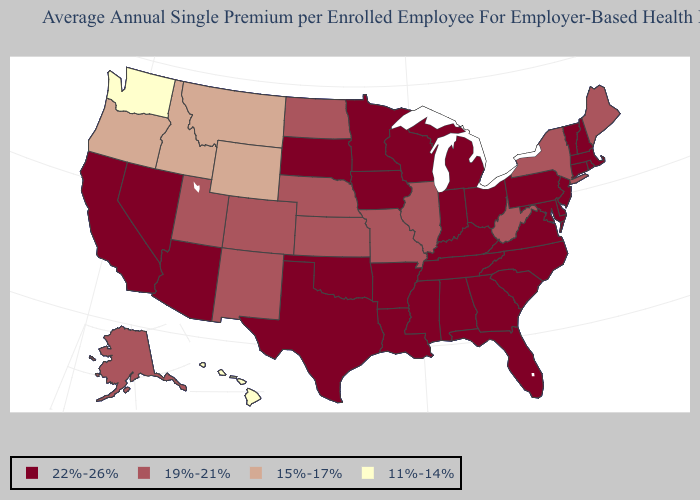What is the highest value in the USA?
Answer briefly. 22%-26%. Name the states that have a value in the range 22%-26%?
Be succinct. Alabama, Arizona, Arkansas, California, Connecticut, Delaware, Florida, Georgia, Indiana, Iowa, Kentucky, Louisiana, Maryland, Massachusetts, Michigan, Minnesota, Mississippi, Nevada, New Hampshire, New Jersey, North Carolina, Ohio, Oklahoma, Pennsylvania, Rhode Island, South Carolina, South Dakota, Tennessee, Texas, Vermont, Virginia, Wisconsin. What is the value of New Hampshire?
Give a very brief answer. 22%-26%. What is the lowest value in the USA?
Give a very brief answer. 11%-14%. What is the highest value in states that border Washington?
Keep it brief. 15%-17%. Name the states that have a value in the range 22%-26%?
Keep it brief. Alabama, Arizona, Arkansas, California, Connecticut, Delaware, Florida, Georgia, Indiana, Iowa, Kentucky, Louisiana, Maryland, Massachusetts, Michigan, Minnesota, Mississippi, Nevada, New Hampshire, New Jersey, North Carolina, Ohio, Oklahoma, Pennsylvania, Rhode Island, South Carolina, South Dakota, Tennessee, Texas, Vermont, Virginia, Wisconsin. Name the states that have a value in the range 19%-21%?
Answer briefly. Alaska, Colorado, Illinois, Kansas, Maine, Missouri, Nebraska, New Mexico, New York, North Dakota, Utah, West Virginia. Among the states that border California , which have the highest value?
Keep it brief. Arizona, Nevada. What is the value of Oregon?
Be succinct. 15%-17%. Does the map have missing data?
Keep it brief. No. Name the states that have a value in the range 19%-21%?
Concise answer only. Alaska, Colorado, Illinois, Kansas, Maine, Missouri, Nebraska, New Mexico, New York, North Dakota, Utah, West Virginia. Does Oregon have the same value as California?
Be succinct. No. Which states have the lowest value in the USA?
Concise answer only. Hawaii, Washington. Does the map have missing data?
Quick response, please. No. 